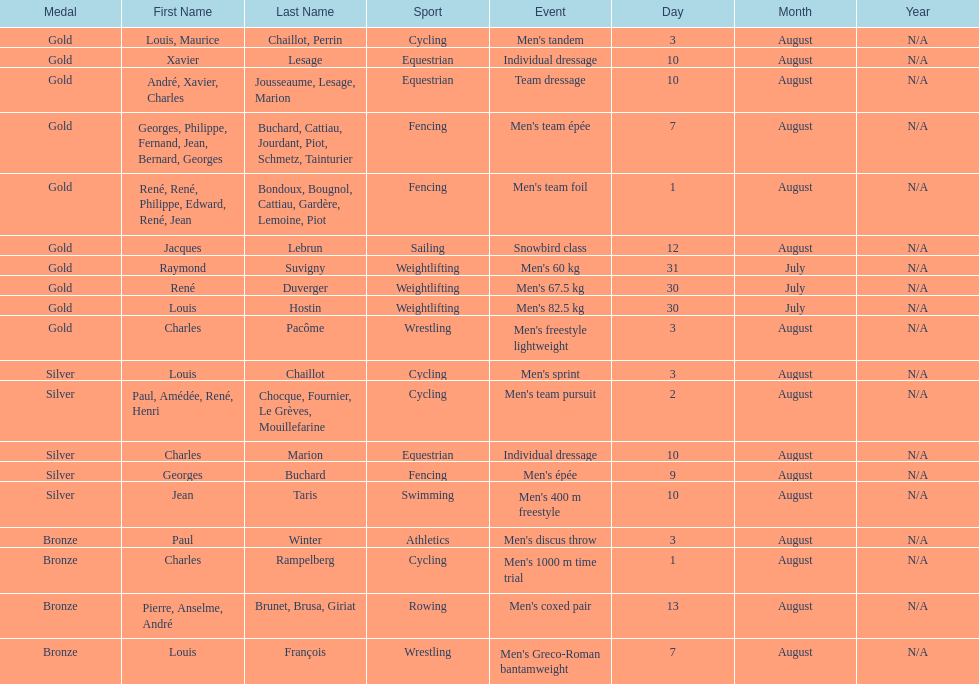What event is listed right before team dressage? Individual dressage. 